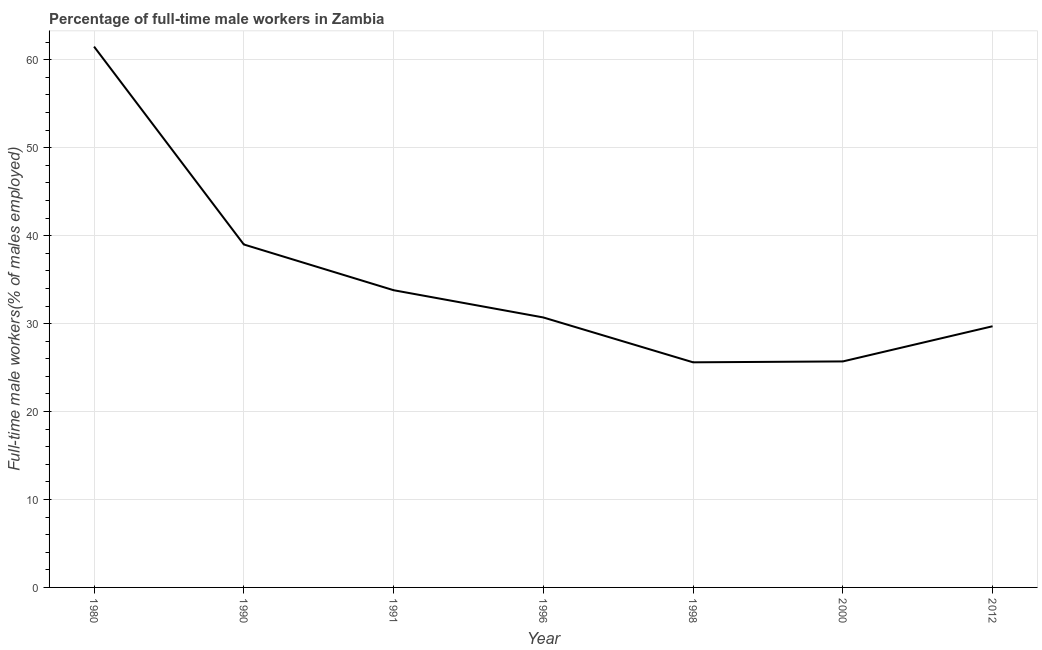What is the percentage of full-time male workers in 1998?
Keep it short and to the point. 25.6. Across all years, what is the maximum percentage of full-time male workers?
Provide a short and direct response. 61.5. Across all years, what is the minimum percentage of full-time male workers?
Keep it short and to the point. 25.6. In which year was the percentage of full-time male workers minimum?
Offer a terse response. 1998. What is the sum of the percentage of full-time male workers?
Offer a very short reply. 246. What is the difference between the percentage of full-time male workers in 1991 and 2000?
Your answer should be very brief. 8.1. What is the average percentage of full-time male workers per year?
Your answer should be compact. 35.14. What is the median percentage of full-time male workers?
Provide a short and direct response. 30.7. In how many years, is the percentage of full-time male workers greater than 8 %?
Make the answer very short. 7. What is the ratio of the percentage of full-time male workers in 1990 to that in 1996?
Your response must be concise. 1.27. Is the percentage of full-time male workers in 1980 less than that in 1996?
Make the answer very short. No. Is the difference between the percentage of full-time male workers in 1990 and 1998 greater than the difference between any two years?
Your response must be concise. No. What is the difference between the highest and the lowest percentage of full-time male workers?
Ensure brevity in your answer.  35.9. In how many years, is the percentage of full-time male workers greater than the average percentage of full-time male workers taken over all years?
Keep it short and to the point. 2. Does the percentage of full-time male workers monotonically increase over the years?
Keep it short and to the point. No. How many years are there in the graph?
Provide a short and direct response. 7. Are the values on the major ticks of Y-axis written in scientific E-notation?
Provide a succinct answer. No. Does the graph contain any zero values?
Provide a succinct answer. No. Does the graph contain grids?
Provide a short and direct response. Yes. What is the title of the graph?
Ensure brevity in your answer.  Percentage of full-time male workers in Zambia. What is the label or title of the Y-axis?
Offer a very short reply. Full-time male workers(% of males employed). What is the Full-time male workers(% of males employed) in 1980?
Ensure brevity in your answer.  61.5. What is the Full-time male workers(% of males employed) in 1990?
Ensure brevity in your answer.  39. What is the Full-time male workers(% of males employed) of 1991?
Provide a short and direct response. 33.8. What is the Full-time male workers(% of males employed) in 1996?
Provide a short and direct response. 30.7. What is the Full-time male workers(% of males employed) in 1998?
Offer a terse response. 25.6. What is the Full-time male workers(% of males employed) in 2000?
Your answer should be compact. 25.7. What is the Full-time male workers(% of males employed) in 2012?
Make the answer very short. 29.7. What is the difference between the Full-time male workers(% of males employed) in 1980 and 1990?
Provide a succinct answer. 22.5. What is the difference between the Full-time male workers(% of males employed) in 1980 and 1991?
Your response must be concise. 27.7. What is the difference between the Full-time male workers(% of males employed) in 1980 and 1996?
Offer a terse response. 30.8. What is the difference between the Full-time male workers(% of males employed) in 1980 and 1998?
Make the answer very short. 35.9. What is the difference between the Full-time male workers(% of males employed) in 1980 and 2000?
Offer a terse response. 35.8. What is the difference between the Full-time male workers(% of males employed) in 1980 and 2012?
Keep it short and to the point. 31.8. What is the difference between the Full-time male workers(% of males employed) in 1990 and 1996?
Keep it short and to the point. 8.3. What is the difference between the Full-time male workers(% of males employed) in 1990 and 1998?
Offer a terse response. 13.4. What is the difference between the Full-time male workers(% of males employed) in 1990 and 2000?
Your response must be concise. 13.3. What is the difference between the Full-time male workers(% of males employed) in 1991 and 2000?
Ensure brevity in your answer.  8.1. What is the difference between the Full-time male workers(% of males employed) in 1996 and 1998?
Provide a short and direct response. 5.1. What is the difference between the Full-time male workers(% of males employed) in 1996 and 2012?
Provide a succinct answer. 1. What is the difference between the Full-time male workers(% of males employed) in 1998 and 2000?
Provide a short and direct response. -0.1. What is the ratio of the Full-time male workers(% of males employed) in 1980 to that in 1990?
Your answer should be compact. 1.58. What is the ratio of the Full-time male workers(% of males employed) in 1980 to that in 1991?
Your answer should be compact. 1.82. What is the ratio of the Full-time male workers(% of males employed) in 1980 to that in 1996?
Your answer should be compact. 2. What is the ratio of the Full-time male workers(% of males employed) in 1980 to that in 1998?
Your answer should be compact. 2.4. What is the ratio of the Full-time male workers(% of males employed) in 1980 to that in 2000?
Offer a terse response. 2.39. What is the ratio of the Full-time male workers(% of males employed) in 1980 to that in 2012?
Your answer should be very brief. 2.07. What is the ratio of the Full-time male workers(% of males employed) in 1990 to that in 1991?
Give a very brief answer. 1.15. What is the ratio of the Full-time male workers(% of males employed) in 1990 to that in 1996?
Ensure brevity in your answer.  1.27. What is the ratio of the Full-time male workers(% of males employed) in 1990 to that in 1998?
Offer a very short reply. 1.52. What is the ratio of the Full-time male workers(% of males employed) in 1990 to that in 2000?
Keep it short and to the point. 1.52. What is the ratio of the Full-time male workers(% of males employed) in 1990 to that in 2012?
Ensure brevity in your answer.  1.31. What is the ratio of the Full-time male workers(% of males employed) in 1991 to that in 1996?
Your answer should be very brief. 1.1. What is the ratio of the Full-time male workers(% of males employed) in 1991 to that in 1998?
Ensure brevity in your answer.  1.32. What is the ratio of the Full-time male workers(% of males employed) in 1991 to that in 2000?
Offer a terse response. 1.31. What is the ratio of the Full-time male workers(% of males employed) in 1991 to that in 2012?
Give a very brief answer. 1.14. What is the ratio of the Full-time male workers(% of males employed) in 1996 to that in 1998?
Offer a terse response. 1.2. What is the ratio of the Full-time male workers(% of males employed) in 1996 to that in 2000?
Give a very brief answer. 1.2. What is the ratio of the Full-time male workers(% of males employed) in 1996 to that in 2012?
Give a very brief answer. 1.03. What is the ratio of the Full-time male workers(% of males employed) in 1998 to that in 2000?
Provide a short and direct response. 1. What is the ratio of the Full-time male workers(% of males employed) in 1998 to that in 2012?
Provide a short and direct response. 0.86. What is the ratio of the Full-time male workers(% of males employed) in 2000 to that in 2012?
Your response must be concise. 0.86. 